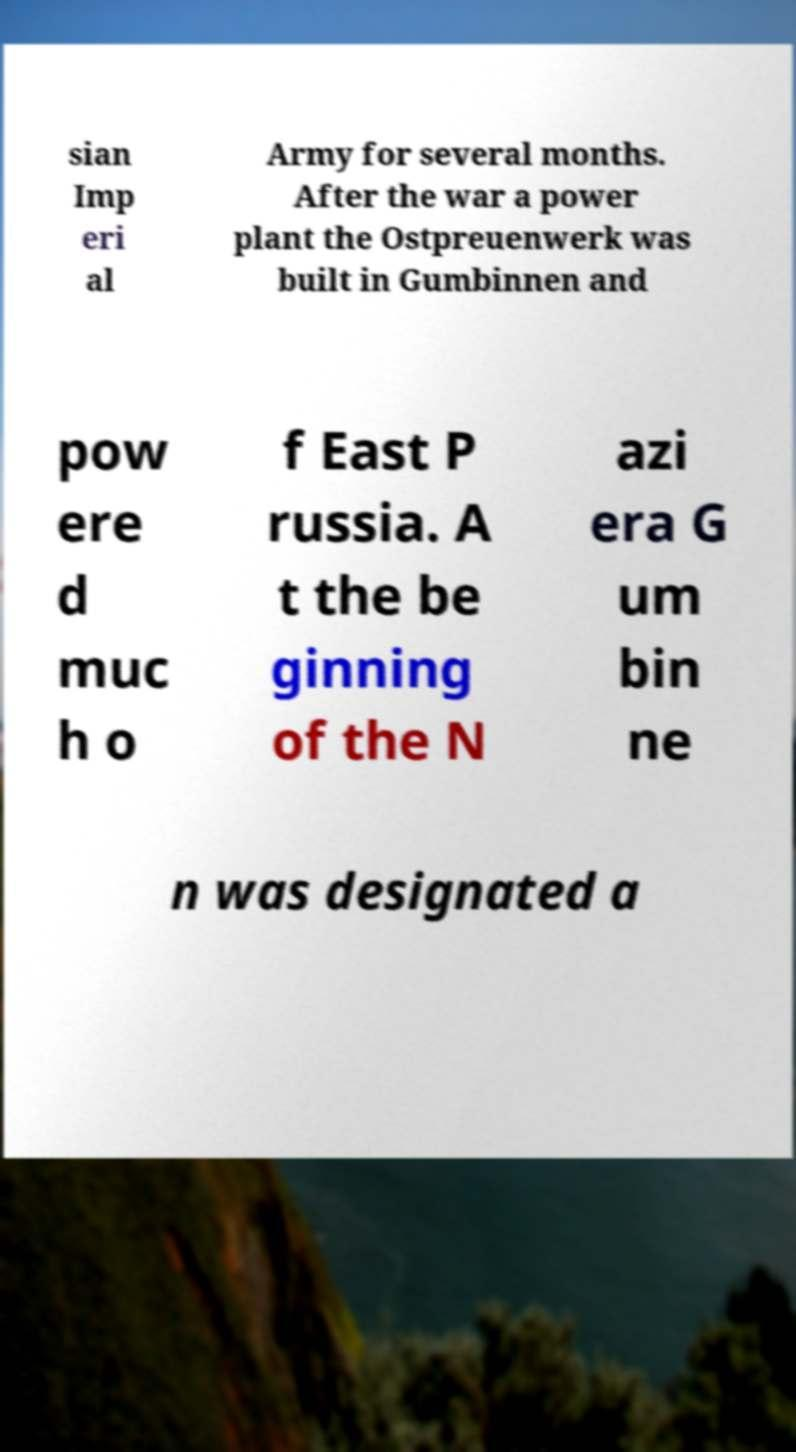Could you assist in decoding the text presented in this image and type it out clearly? sian Imp eri al Army for several months. After the war a power plant the Ostpreuenwerk was built in Gumbinnen and pow ere d muc h o f East P russia. A t the be ginning of the N azi era G um bin ne n was designated a 